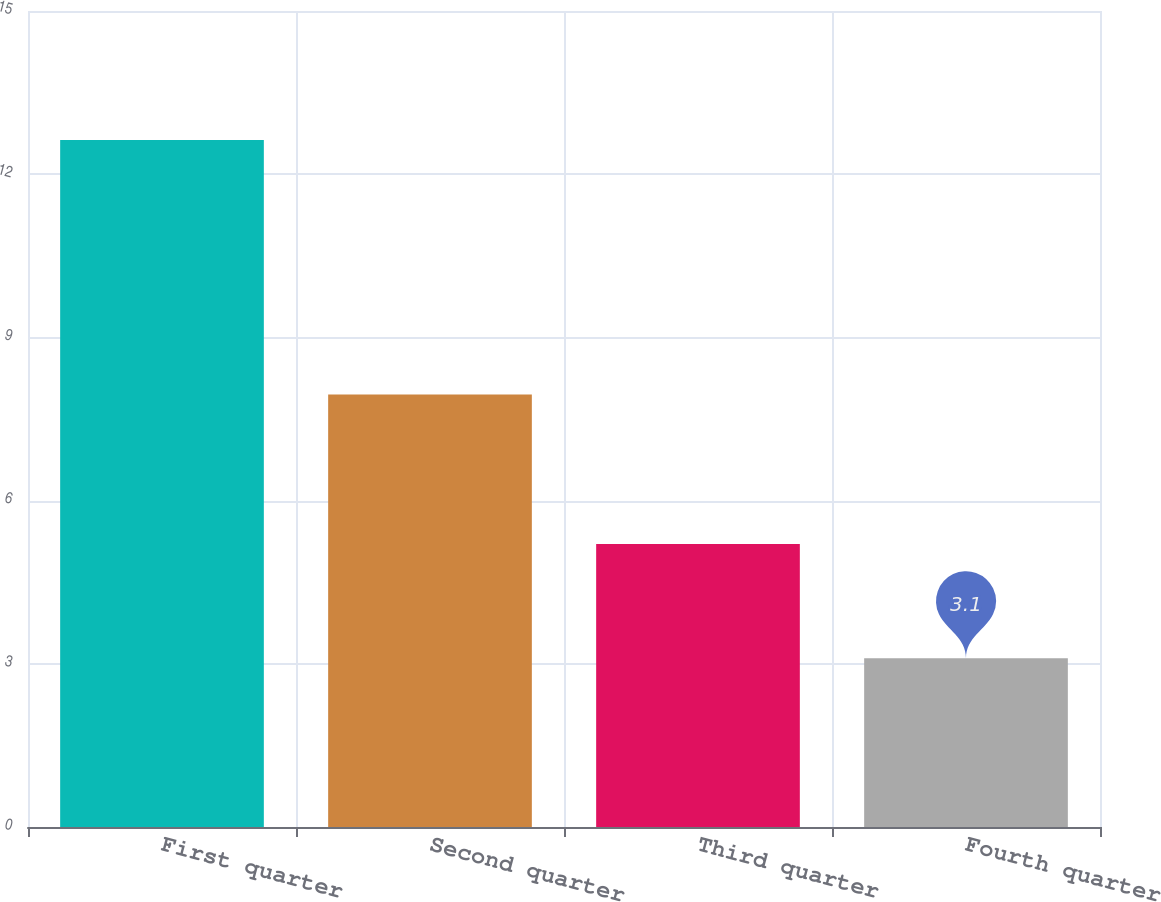Convert chart. <chart><loc_0><loc_0><loc_500><loc_500><bar_chart><fcel>First quarter<fcel>Second quarter<fcel>Third quarter<fcel>Fourth quarter<nl><fcel>12.63<fcel>7.95<fcel>5.2<fcel>3.1<nl></chart> 